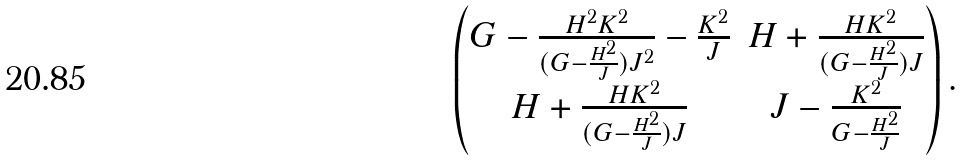<formula> <loc_0><loc_0><loc_500><loc_500>\begin{pmatrix} G - \frac { H ^ { 2 } K ^ { 2 } } { ( G - \frac { H ^ { 2 } } { J } ) J ^ { 2 } } - \frac { K ^ { 2 } } { J } & H + \frac { H K ^ { 2 } } { ( G - \frac { H ^ { 2 } } { J } ) J } \\ H + \frac { H K ^ { 2 } } { ( G - \frac { H ^ { 2 } } { J } ) J } & J - \frac { K ^ { 2 } } { G - \frac { H ^ { 2 } } { J } } \end{pmatrix} .</formula> 